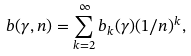Convert formula to latex. <formula><loc_0><loc_0><loc_500><loc_500>b ( \gamma , n ) = \sum _ { k = 2 } ^ { \infty } b _ { k } ( \gamma ) ( 1 / n ) ^ { k } ,</formula> 